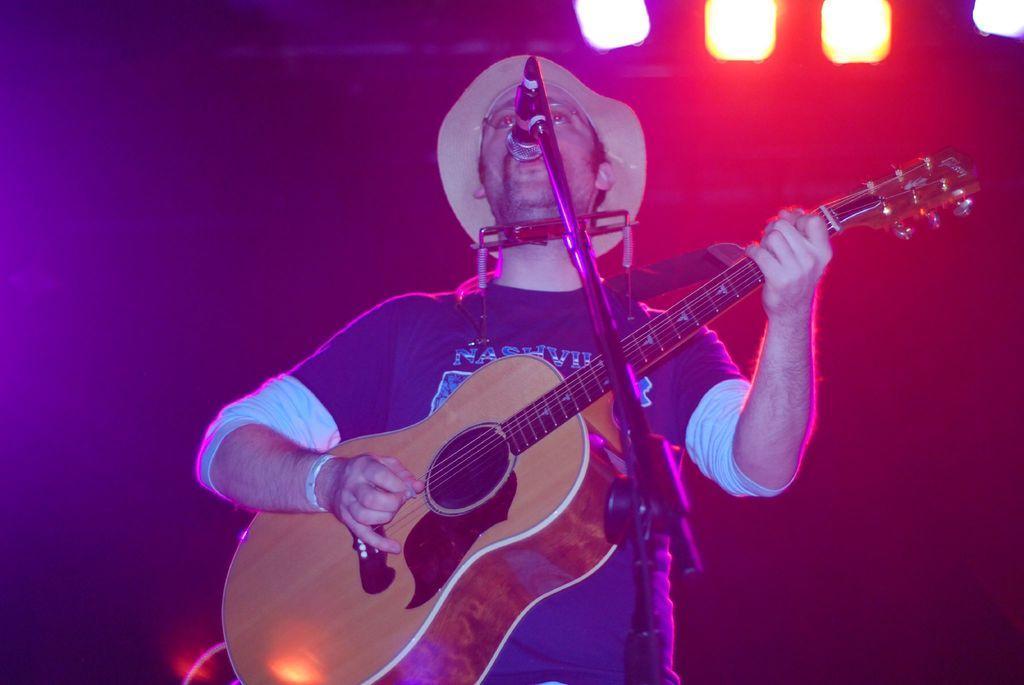Could you give a brief overview of what you see in this image? In this picture there is a person standing and holding guitar and singing. This is microphone with stand. On the background we can see focusing lights. 